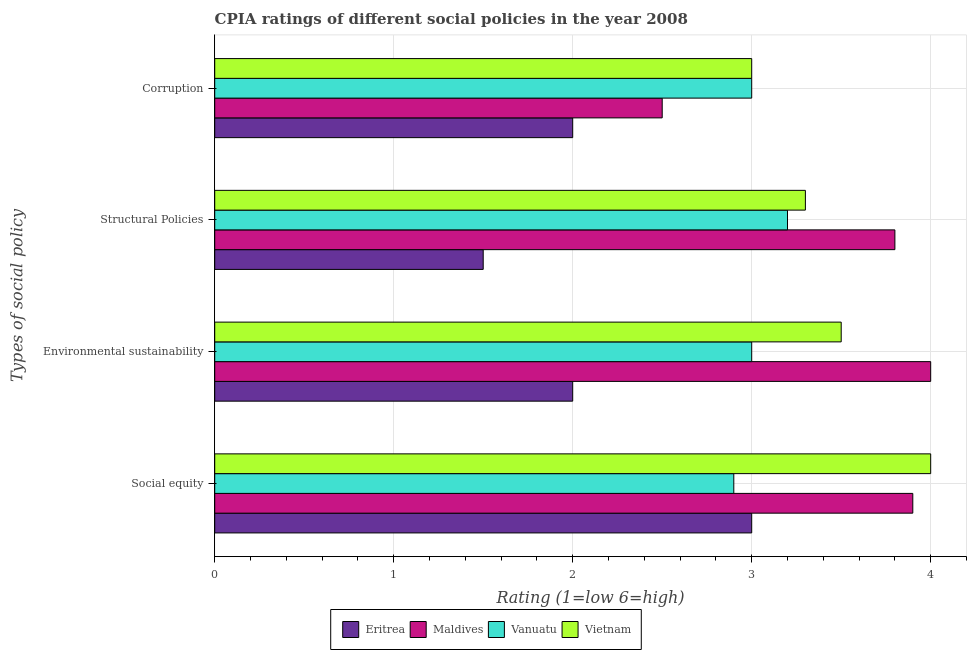How many groups of bars are there?
Offer a very short reply. 4. Are the number of bars per tick equal to the number of legend labels?
Offer a terse response. Yes. How many bars are there on the 3rd tick from the top?
Keep it short and to the point. 4. What is the label of the 1st group of bars from the top?
Your answer should be very brief. Corruption. Across all countries, what is the maximum cpia rating of environmental sustainability?
Offer a terse response. 4. In which country was the cpia rating of social equity maximum?
Your answer should be compact. Vietnam. In which country was the cpia rating of environmental sustainability minimum?
Ensure brevity in your answer.  Eritrea. What is the total cpia rating of social equity in the graph?
Offer a very short reply. 13.8. What is the difference between the cpia rating of social equity in Maldives and the cpia rating of environmental sustainability in Vanuatu?
Offer a terse response. 0.9. What is the average cpia rating of corruption per country?
Keep it short and to the point. 2.62. Is the cpia rating of corruption in Vietnam less than that in Maldives?
Keep it short and to the point. No. What is the difference between the highest and the lowest cpia rating of corruption?
Your response must be concise. 1. Is it the case that in every country, the sum of the cpia rating of corruption and cpia rating of social equity is greater than the sum of cpia rating of structural policies and cpia rating of environmental sustainability?
Ensure brevity in your answer.  No. What does the 4th bar from the top in Corruption represents?
Offer a very short reply. Eritrea. What does the 3rd bar from the bottom in Social equity represents?
Your response must be concise. Vanuatu. Is it the case that in every country, the sum of the cpia rating of social equity and cpia rating of environmental sustainability is greater than the cpia rating of structural policies?
Provide a short and direct response. Yes. How many bars are there?
Ensure brevity in your answer.  16. Does the graph contain any zero values?
Your response must be concise. No. Does the graph contain grids?
Give a very brief answer. Yes. Where does the legend appear in the graph?
Your answer should be compact. Bottom center. How many legend labels are there?
Make the answer very short. 4. How are the legend labels stacked?
Offer a very short reply. Horizontal. What is the title of the graph?
Make the answer very short. CPIA ratings of different social policies in the year 2008. What is the label or title of the Y-axis?
Give a very brief answer. Types of social policy. What is the Rating (1=low 6=high) of Eritrea in Social equity?
Give a very brief answer. 3. What is the Rating (1=low 6=high) of Maldives in Social equity?
Provide a short and direct response. 3.9. What is the Rating (1=low 6=high) in Vietnam in Social equity?
Offer a very short reply. 4. What is the Rating (1=low 6=high) in Eritrea in Environmental sustainability?
Give a very brief answer. 2. What is the Rating (1=low 6=high) of Maldives in Environmental sustainability?
Offer a terse response. 4. What is the Rating (1=low 6=high) of Vanuatu in Environmental sustainability?
Your answer should be compact. 3. What is the Rating (1=low 6=high) of Vietnam in Environmental sustainability?
Offer a terse response. 3.5. What is the Rating (1=low 6=high) in Vanuatu in Structural Policies?
Provide a succinct answer. 3.2. What is the Rating (1=low 6=high) of Vanuatu in Corruption?
Your response must be concise. 3. What is the Rating (1=low 6=high) in Vietnam in Corruption?
Your answer should be very brief. 3. Across all Types of social policy, what is the maximum Rating (1=low 6=high) of Eritrea?
Make the answer very short. 3. Across all Types of social policy, what is the maximum Rating (1=low 6=high) of Maldives?
Keep it short and to the point. 4. Across all Types of social policy, what is the maximum Rating (1=low 6=high) in Vanuatu?
Give a very brief answer. 3.2. Across all Types of social policy, what is the maximum Rating (1=low 6=high) in Vietnam?
Ensure brevity in your answer.  4. Across all Types of social policy, what is the minimum Rating (1=low 6=high) in Eritrea?
Your answer should be very brief. 1.5. Across all Types of social policy, what is the minimum Rating (1=low 6=high) of Maldives?
Offer a terse response. 2.5. Across all Types of social policy, what is the minimum Rating (1=low 6=high) in Vanuatu?
Give a very brief answer. 2.9. What is the total Rating (1=low 6=high) in Eritrea in the graph?
Provide a succinct answer. 8.5. What is the total Rating (1=low 6=high) of Vietnam in the graph?
Your answer should be very brief. 13.8. What is the difference between the Rating (1=low 6=high) in Eritrea in Social equity and that in Environmental sustainability?
Make the answer very short. 1. What is the difference between the Rating (1=low 6=high) of Vanuatu in Social equity and that in Environmental sustainability?
Make the answer very short. -0.1. What is the difference between the Rating (1=low 6=high) in Eritrea in Social equity and that in Structural Policies?
Your response must be concise. 1.5. What is the difference between the Rating (1=low 6=high) in Vanuatu in Social equity and that in Structural Policies?
Your answer should be very brief. -0.3. What is the difference between the Rating (1=low 6=high) in Vietnam in Social equity and that in Structural Policies?
Offer a very short reply. 0.7. What is the difference between the Rating (1=low 6=high) in Maldives in Social equity and that in Corruption?
Your answer should be very brief. 1.4. What is the difference between the Rating (1=low 6=high) in Vanuatu in Social equity and that in Corruption?
Provide a succinct answer. -0.1. What is the difference between the Rating (1=low 6=high) in Vietnam in Social equity and that in Corruption?
Offer a very short reply. 1. What is the difference between the Rating (1=low 6=high) in Eritrea in Environmental sustainability and that in Structural Policies?
Offer a terse response. 0.5. What is the difference between the Rating (1=low 6=high) of Maldives in Environmental sustainability and that in Structural Policies?
Provide a succinct answer. 0.2. What is the difference between the Rating (1=low 6=high) in Eritrea in Environmental sustainability and that in Corruption?
Offer a terse response. 0. What is the difference between the Rating (1=low 6=high) in Maldives in Environmental sustainability and that in Corruption?
Offer a very short reply. 1.5. What is the difference between the Rating (1=low 6=high) in Vietnam in Environmental sustainability and that in Corruption?
Offer a terse response. 0.5. What is the difference between the Rating (1=low 6=high) of Eritrea in Structural Policies and that in Corruption?
Keep it short and to the point. -0.5. What is the difference between the Rating (1=low 6=high) of Maldives in Structural Policies and that in Corruption?
Ensure brevity in your answer.  1.3. What is the difference between the Rating (1=low 6=high) in Eritrea in Social equity and the Rating (1=low 6=high) in Vanuatu in Environmental sustainability?
Make the answer very short. 0. What is the difference between the Rating (1=low 6=high) of Eritrea in Social equity and the Rating (1=low 6=high) of Vietnam in Environmental sustainability?
Give a very brief answer. -0.5. What is the difference between the Rating (1=low 6=high) of Maldives in Social equity and the Rating (1=low 6=high) of Vietnam in Environmental sustainability?
Offer a very short reply. 0.4. What is the difference between the Rating (1=low 6=high) of Eritrea in Social equity and the Rating (1=low 6=high) of Vanuatu in Structural Policies?
Your answer should be compact. -0.2. What is the difference between the Rating (1=low 6=high) of Eritrea in Social equity and the Rating (1=low 6=high) of Vietnam in Structural Policies?
Your response must be concise. -0.3. What is the difference between the Rating (1=low 6=high) of Maldives in Social equity and the Rating (1=low 6=high) of Vanuatu in Structural Policies?
Offer a terse response. 0.7. What is the difference between the Rating (1=low 6=high) in Maldives in Social equity and the Rating (1=low 6=high) in Vietnam in Structural Policies?
Provide a short and direct response. 0.6. What is the difference between the Rating (1=low 6=high) of Vanuatu in Social equity and the Rating (1=low 6=high) of Vietnam in Structural Policies?
Offer a very short reply. -0.4. What is the difference between the Rating (1=low 6=high) in Eritrea in Social equity and the Rating (1=low 6=high) in Maldives in Corruption?
Offer a terse response. 0.5. What is the difference between the Rating (1=low 6=high) in Eritrea in Social equity and the Rating (1=low 6=high) in Vanuatu in Corruption?
Your answer should be very brief. 0. What is the difference between the Rating (1=low 6=high) in Maldives in Social equity and the Rating (1=low 6=high) in Vietnam in Corruption?
Make the answer very short. 0.9. What is the difference between the Rating (1=low 6=high) of Eritrea in Environmental sustainability and the Rating (1=low 6=high) of Maldives in Structural Policies?
Offer a terse response. -1.8. What is the difference between the Rating (1=low 6=high) of Eritrea in Environmental sustainability and the Rating (1=low 6=high) of Vanuatu in Structural Policies?
Provide a succinct answer. -1.2. What is the difference between the Rating (1=low 6=high) in Eritrea in Environmental sustainability and the Rating (1=low 6=high) in Vietnam in Structural Policies?
Make the answer very short. -1.3. What is the difference between the Rating (1=low 6=high) in Maldives in Environmental sustainability and the Rating (1=low 6=high) in Vanuatu in Structural Policies?
Offer a very short reply. 0.8. What is the difference between the Rating (1=low 6=high) of Maldives in Environmental sustainability and the Rating (1=low 6=high) of Vietnam in Structural Policies?
Ensure brevity in your answer.  0.7. What is the difference between the Rating (1=low 6=high) of Eritrea in Environmental sustainability and the Rating (1=low 6=high) of Maldives in Corruption?
Your answer should be very brief. -0.5. What is the difference between the Rating (1=low 6=high) of Maldives in Environmental sustainability and the Rating (1=low 6=high) of Vietnam in Corruption?
Make the answer very short. 1. What is the difference between the Rating (1=low 6=high) in Vanuatu in Environmental sustainability and the Rating (1=low 6=high) in Vietnam in Corruption?
Ensure brevity in your answer.  0. What is the difference between the Rating (1=low 6=high) of Eritrea in Structural Policies and the Rating (1=low 6=high) of Vanuatu in Corruption?
Make the answer very short. -1.5. What is the average Rating (1=low 6=high) of Eritrea per Types of social policy?
Your response must be concise. 2.12. What is the average Rating (1=low 6=high) in Maldives per Types of social policy?
Offer a very short reply. 3.55. What is the average Rating (1=low 6=high) in Vanuatu per Types of social policy?
Keep it short and to the point. 3.02. What is the average Rating (1=low 6=high) in Vietnam per Types of social policy?
Your answer should be compact. 3.45. What is the difference between the Rating (1=low 6=high) in Eritrea and Rating (1=low 6=high) in Maldives in Social equity?
Your answer should be compact. -0.9. What is the difference between the Rating (1=low 6=high) of Eritrea and Rating (1=low 6=high) of Vietnam in Social equity?
Offer a very short reply. -1. What is the difference between the Rating (1=low 6=high) in Maldives and Rating (1=low 6=high) in Vanuatu in Social equity?
Offer a terse response. 1. What is the difference between the Rating (1=low 6=high) in Maldives and Rating (1=low 6=high) in Vietnam in Social equity?
Offer a very short reply. -0.1. What is the difference between the Rating (1=low 6=high) in Vanuatu and Rating (1=low 6=high) in Vietnam in Social equity?
Your answer should be compact. -1.1. What is the difference between the Rating (1=low 6=high) of Eritrea and Rating (1=low 6=high) of Maldives in Environmental sustainability?
Give a very brief answer. -2. What is the difference between the Rating (1=low 6=high) in Eritrea and Rating (1=low 6=high) in Vanuatu in Environmental sustainability?
Provide a succinct answer. -1. What is the difference between the Rating (1=low 6=high) in Maldives and Rating (1=low 6=high) in Vanuatu in Environmental sustainability?
Provide a succinct answer. 1. What is the difference between the Rating (1=low 6=high) in Maldives and Rating (1=low 6=high) in Vietnam in Environmental sustainability?
Provide a short and direct response. 0.5. What is the difference between the Rating (1=low 6=high) in Vanuatu and Rating (1=low 6=high) in Vietnam in Environmental sustainability?
Provide a short and direct response. -0.5. What is the difference between the Rating (1=low 6=high) in Eritrea and Rating (1=low 6=high) in Vanuatu in Structural Policies?
Offer a terse response. -1.7. What is the difference between the Rating (1=low 6=high) of Eritrea and Rating (1=low 6=high) of Vietnam in Structural Policies?
Provide a succinct answer. -1.8. What is the difference between the Rating (1=low 6=high) of Maldives and Rating (1=low 6=high) of Vanuatu in Structural Policies?
Provide a succinct answer. 0.6. What is the difference between the Rating (1=low 6=high) in Maldives and Rating (1=low 6=high) in Vietnam in Structural Policies?
Your response must be concise. 0.5. What is the difference between the Rating (1=low 6=high) of Vanuatu and Rating (1=low 6=high) of Vietnam in Structural Policies?
Your answer should be very brief. -0.1. What is the difference between the Rating (1=low 6=high) in Eritrea and Rating (1=low 6=high) in Maldives in Corruption?
Keep it short and to the point. -0.5. What is the difference between the Rating (1=low 6=high) in Maldives and Rating (1=low 6=high) in Vanuatu in Corruption?
Ensure brevity in your answer.  -0.5. What is the difference between the Rating (1=low 6=high) of Maldives and Rating (1=low 6=high) of Vietnam in Corruption?
Offer a terse response. -0.5. What is the ratio of the Rating (1=low 6=high) in Eritrea in Social equity to that in Environmental sustainability?
Your response must be concise. 1.5. What is the ratio of the Rating (1=low 6=high) in Maldives in Social equity to that in Environmental sustainability?
Your answer should be compact. 0.97. What is the ratio of the Rating (1=low 6=high) in Vanuatu in Social equity to that in Environmental sustainability?
Give a very brief answer. 0.97. What is the ratio of the Rating (1=low 6=high) of Vietnam in Social equity to that in Environmental sustainability?
Your answer should be compact. 1.14. What is the ratio of the Rating (1=low 6=high) in Eritrea in Social equity to that in Structural Policies?
Provide a succinct answer. 2. What is the ratio of the Rating (1=low 6=high) of Maldives in Social equity to that in Structural Policies?
Make the answer very short. 1.03. What is the ratio of the Rating (1=low 6=high) of Vanuatu in Social equity to that in Structural Policies?
Offer a terse response. 0.91. What is the ratio of the Rating (1=low 6=high) in Vietnam in Social equity to that in Structural Policies?
Offer a very short reply. 1.21. What is the ratio of the Rating (1=low 6=high) in Maldives in Social equity to that in Corruption?
Give a very brief answer. 1.56. What is the ratio of the Rating (1=low 6=high) in Vanuatu in Social equity to that in Corruption?
Ensure brevity in your answer.  0.97. What is the ratio of the Rating (1=low 6=high) of Eritrea in Environmental sustainability to that in Structural Policies?
Offer a very short reply. 1.33. What is the ratio of the Rating (1=low 6=high) of Maldives in Environmental sustainability to that in Structural Policies?
Your answer should be very brief. 1.05. What is the ratio of the Rating (1=low 6=high) in Vanuatu in Environmental sustainability to that in Structural Policies?
Your answer should be compact. 0.94. What is the ratio of the Rating (1=low 6=high) in Vietnam in Environmental sustainability to that in Structural Policies?
Keep it short and to the point. 1.06. What is the ratio of the Rating (1=low 6=high) of Vanuatu in Environmental sustainability to that in Corruption?
Your response must be concise. 1. What is the ratio of the Rating (1=low 6=high) of Vietnam in Environmental sustainability to that in Corruption?
Offer a terse response. 1.17. What is the ratio of the Rating (1=low 6=high) in Eritrea in Structural Policies to that in Corruption?
Your answer should be compact. 0.75. What is the ratio of the Rating (1=low 6=high) of Maldives in Structural Policies to that in Corruption?
Provide a short and direct response. 1.52. What is the ratio of the Rating (1=low 6=high) in Vanuatu in Structural Policies to that in Corruption?
Provide a short and direct response. 1.07. What is the difference between the highest and the second highest Rating (1=low 6=high) in Eritrea?
Your answer should be compact. 1. What is the difference between the highest and the second highest Rating (1=low 6=high) of Maldives?
Your answer should be compact. 0.1. What is the difference between the highest and the second highest Rating (1=low 6=high) of Vietnam?
Offer a very short reply. 0.5. What is the difference between the highest and the lowest Rating (1=low 6=high) of Vietnam?
Provide a short and direct response. 1. 